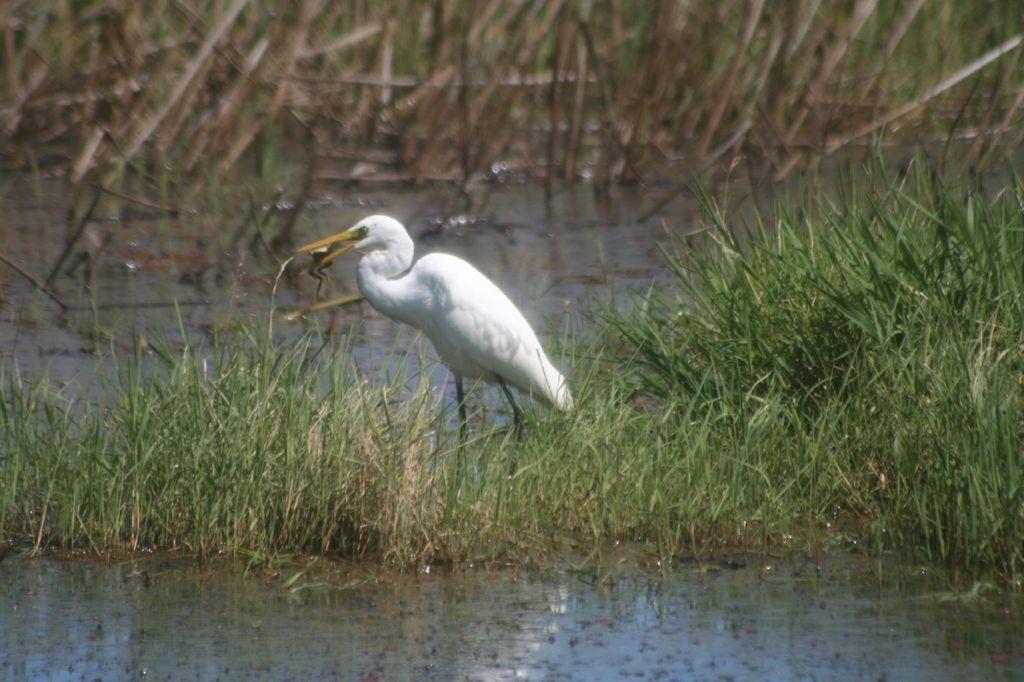Can you describe this image briefly? In the center of the image we can see crane on the grass. At the bottom of the image there is water. In the background we can see plants. 